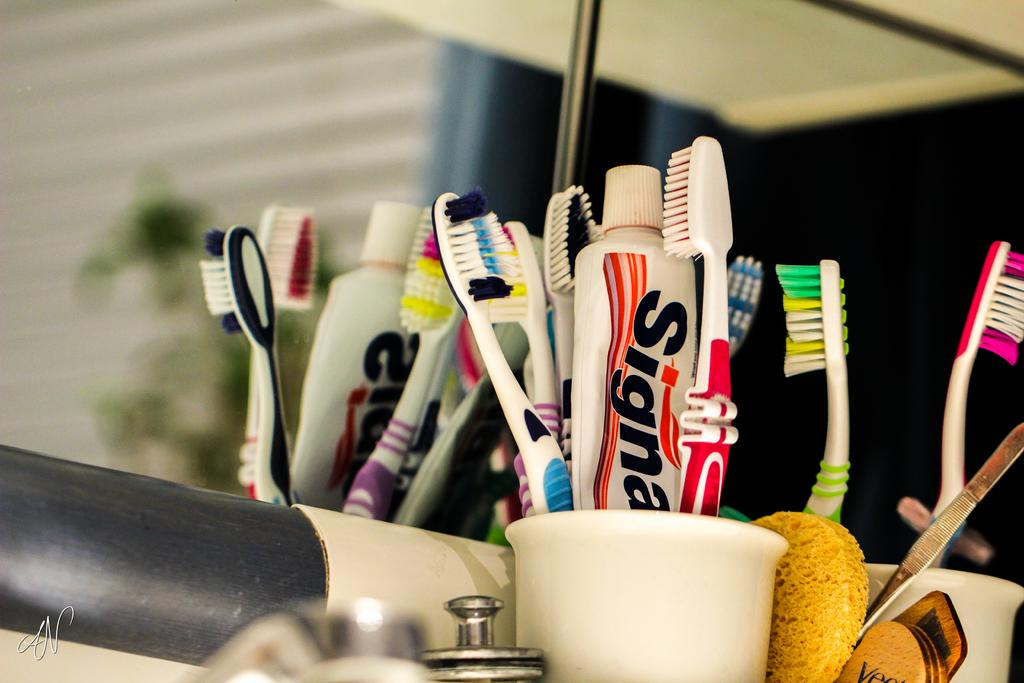What is the main item featured in the image? There is toothpaste in the image. What other items are related to the main item? There are brushes in the image. How are the toothpaste and brushes organized in the image? The toothpaste and brushes are in a holder. What can be used for personal grooming in the image? There is a mirror in the image. What additional detail can be found in the bottom left of the image? A tag is present in the bottom left of the image. What type of gold can be seen in the image? There is no gold present in the image. What impulse might someone have when looking at the toothpaste and brushes in the image? It is not possible to determine someone's impulse from the image alone. 